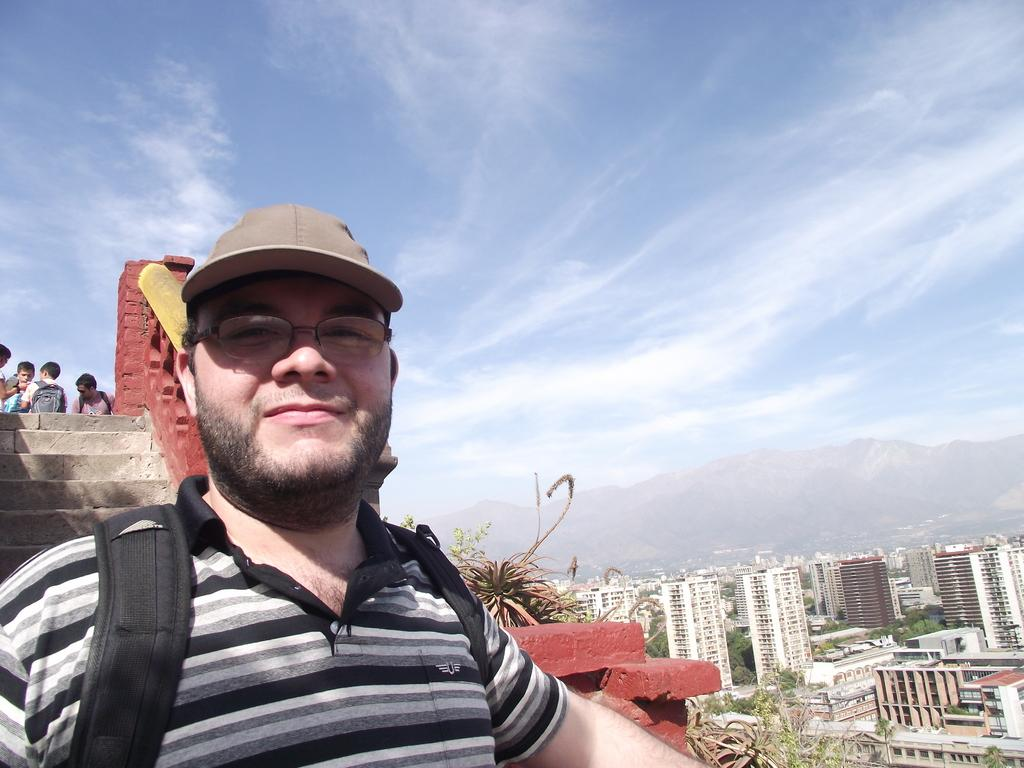Who is the main subject in the image? There is a man in the image. What can be seen in the background of the image? There are people, steps, buildings, trees, mountains, and the sky visible in the background of the image. What type of wine is being served at the slope in the image? There is no slope or wine present in the image. 